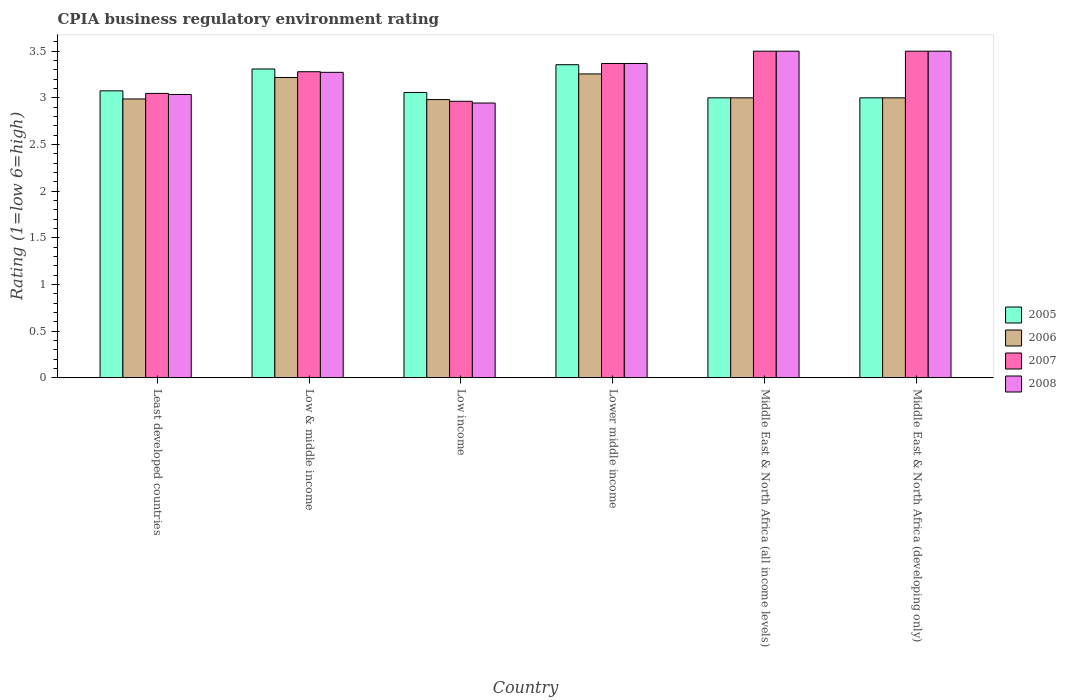Are the number of bars per tick equal to the number of legend labels?
Make the answer very short. Yes. Are the number of bars on each tick of the X-axis equal?
Provide a short and direct response. Yes. How many bars are there on the 6th tick from the left?
Provide a succinct answer. 4. How many bars are there on the 4th tick from the right?
Your answer should be very brief. 4. In how many cases, is the number of bars for a given country not equal to the number of legend labels?
Your response must be concise. 0. What is the CPIA rating in 2006 in Low & middle income?
Give a very brief answer. 3.22. Across all countries, what is the maximum CPIA rating in 2005?
Keep it short and to the point. 3.36. Across all countries, what is the minimum CPIA rating in 2007?
Make the answer very short. 2.96. In which country was the CPIA rating in 2008 maximum?
Your response must be concise. Middle East & North Africa (all income levels). What is the total CPIA rating in 2008 in the graph?
Your answer should be very brief. 19.62. What is the difference between the CPIA rating in 2008 in Low & middle income and that in Lower middle income?
Make the answer very short. -0.1. What is the difference between the CPIA rating in 2007 in Low income and the CPIA rating in 2006 in Lower middle income?
Offer a terse response. -0.29. What is the average CPIA rating in 2005 per country?
Your answer should be very brief. 3.13. What is the difference between the CPIA rating of/in 2005 and CPIA rating of/in 2007 in Low & middle income?
Your response must be concise. 0.03. What is the ratio of the CPIA rating in 2005 in Lower middle income to that in Middle East & North Africa (all income levels)?
Ensure brevity in your answer.  1.12. What is the difference between the highest and the second highest CPIA rating in 2008?
Offer a terse response. -0.13. What is the difference between the highest and the lowest CPIA rating in 2006?
Provide a short and direct response. 0.27. In how many countries, is the CPIA rating in 2008 greater than the average CPIA rating in 2008 taken over all countries?
Ensure brevity in your answer.  4. Is the sum of the CPIA rating in 2008 in Low income and Middle East & North Africa (developing only) greater than the maximum CPIA rating in 2005 across all countries?
Your response must be concise. Yes. Is it the case that in every country, the sum of the CPIA rating in 2008 and CPIA rating in 2005 is greater than the sum of CPIA rating in 2006 and CPIA rating in 2007?
Provide a short and direct response. No. What does the 1st bar from the left in Middle East & North Africa (all income levels) represents?
Your answer should be compact. 2005. Is it the case that in every country, the sum of the CPIA rating in 2007 and CPIA rating in 2008 is greater than the CPIA rating in 2006?
Give a very brief answer. Yes. How many bars are there?
Offer a very short reply. 24. What is the difference between two consecutive major ticks on the Y-axis?
Keep it short and to the point. 0.5. Are the values on the major ticks of Y-axis written in scientific E-notation?
Your response must be concise. No. Where does the legend appear in the graph?
Ensure brevity in your answer.  Center right. What is the title of the graph?
Ensure brevity in your answer.  CPIA business regulatory environment rating. What is the label or title of the X-axis?
Your answer should be very brief. Country. What is the Rating (1=low 6=high) of 2005 in Least developed countries?
Keep it short and to the point. 3.08. What is the Rating (1=low 6=high) in 2006 in Least developed countries?
Your answer should be compact. 2.99. What is the Rating (1=low 6=high) in 2007 in Least developed countries?
Give a very brief answer. 3.05. What is the Rating (1=low 6=high) of 2008 in Least developed countries?
Keep it short and to the point. 3.04. What is the Rating (1=low 6=high) of 2005 in Low & middle income?
Provide a short and direct response. 3.31. What is the Rating (1=low 6=high) in 2006 in Low & middle income?
Give a very brief answer. 3.22. What is the Rating (1=low 6=high) in 2007 in Low & middle income?
Your response must be concise. 3.28. What is the Rating (1=low 6=high) in 2008 in Low & middle income?
Provide a short and direct response. 3.27. What is the Rating (1=low 6=high) in 2005 in Low income?
Offer a very short reply. 3.06. What is the Rating (1=low 6=high) of 2006 in Low income?
Provide a short and direct response. 2.98. What is the Rating (1=low 6=high) in 2007 in Low income?
Provide a short and direct response. 2.96. What is the Rating (1=low 6=high) of 2008 in Low income?
Provide a short and direct response. 2.94. What is the Rating (1=low 6=high) in 2005 in Lower middle income?
Offer a terse response. 3.36. What is the Rating (1=low 6=high) of 2006 in Lower middle income?
Give a very brief answer. 3.26. What is the Rating (1=low 6=high) in 2007 in Lower middle income?
Provide a short and direct response. 3.37. What is the Rating (1=low 6=high) of 2008 in Lower middle income?
Offer a terse response. 3.37. What is the Rating (1=low 6=high) of 2007 in Middle East & North Africa (all income levels)?
Your answer should be compact. 3.5. What is the Rating (1=low 6=high) in 2008 in Middle East & North Africa (all income levels)?
Offer a terse response. 3.5. Across all countries, what is the maximum Rating (1=low 6=high) in 2005?
Keep it short and to the point. 3.36. Across all countries, what is the maximum Rating (1=low 6=high) of 2006?
Your answer should be very brief. 3.26. Across all countries, what is the maximum Rating (1=low 6=high) in 2007?
Your answer should be compact. 3.5. Across all countries, what is the minimum Rating (1=low 6=high) of 2006?
Offer a terse response. 2.98. Across all countries, what is the minimum Rating (1=low 6=high) of 2007?
Keep it short and to the point. 2.96. Across all countries, what is the minimum Rating (1=low 6=high) in 2008?
Your answer should be compact. 2.94. What is the total Rating (1=low 6=high) of 2005 in the graph?
Provide a succinct answer. 18.8. What is the total Rating (1=low 6=high) in 2006 in the graph?
Offer a very short reply. 18.44. What is the total Rating (1=low 6=high) in 2007 in the graph?
Make the answer very short. 19.66. What is the total Rating (1=low 6=high) of 2008 in the graph?
Ensure brevity in your answer.  19.62. What is the difference between the Rating (1=low 6=high) in 2005 in Least developed countries and that in Low & middle income?
Provide a short and direct response. -0.23. What is the difference between the Rating (1=low 6=high) of 2006 in Least developed countries and that in Low & middle income?
Provide a succinct answer. -0.23. What is the difference between the Rating (1=low 6=high) of 2007 in Least developed countries and that in Low & middle income?
Provide a short and direct response. -0.23. What is the difference between the Rating (1=low 6=high) of 2008 in Least developed countries and that in Low & middle income?
Make the answer very short. -0.24. What is the difference between the Rating (1=low 6=high) of 2005 in Least developed countries and that in Low income?
Your answer should be compact. 0.02. What is the difference between the Rating (1=low 6=high) in 2006 in Least developed countries and that in Low income?
Your response must be concise. 0.01. What is the difference between the Rating (1=low 6=high) of 2007 in Least developed countries and that in Low income?
Your answer should be very brief. 0.08. What is the difference between the Rating (1=low 6=high) in 2008 in Least developed countries and that in Low income?
Offer a terse response. 0.09. What is the difference between the Rating (1=low 6=high) of 2005 in Least developed countries and that in Lower middle income?
Offer a terse response. -0.28. What is the difference between the Rating (1=low 6=high) in 2006 in Least developed countries and that in Lower middle income?
Your answer should be compact. -0.27. What is the difference between the Rating (1=low 6=high) in 2007 in Least developed countries and that in Lower middle income?
Offer a very short reply. -0.32. What is the difference between the Rating (1=low 6=high) in 2008 in Least developed countries and that in Lower middle income?
Keep it short and to the point. -0.33. What is the difference between the Rating (1=low 6=high) in 2005 in Least developed countries and that in Middle East & North Africa (all income levels)?
Give a very brief answer. 0.07. What is the difference between the Rating (1=low 6=high) in 2006 in Least developed countries and that in Middle East & North Africa (all income levels)?
Ensure brevity in your answer.  -0.01. What is the difference between the Rating (1=low 6=high) in 2007 in Least developed countries and that in Middle East & North Africa (all income levels)?
Ensure brevity in your answer.  -0.45. What is the difference between the Rating (1=low 6=high) of 2008 in Least developed countries and that in Middle East & North Africa (all income levels)?
Your answer should be very brief. -0.46. What is the difference between the Rating (1=low 6=high) of 2005 in Least developed countries and that in Middle East & North Africa (developing only)?
Give a very brief answer. 0.07. What is the difference between the Rating (1=low 6=high) of 2006 in Least developed countries and that in Middle East & North Africa (developing only)?
Keep it short and to the point. -0.01. What is the difference between the Rating (1=low 6=high) of 2007 in Least developed countries and that in Middle East & North Africa (developing only)?
Give a very brief answer. -0.45. What is the difference between the Rating (1=low 6=high) in 2008 in Least developed countries and that in Middle East & North Africa (developing only)?
Offer a terse response. -0.46. What is the difference between the Rating (1=low 6=high) in 2005 in Low & middle income and that in Low income?
Give a very brief answer. 0.25. What is the difference between the Rating (1=low 6=high) in 2006 in Low & middle income and that in Low income?
Ensure brevity in your answer.  0.24. What is the difference between the Rating (1=low 6=high) in 2007 in Low & middle income and that in Low income?
Offer a very short reply. 0.32. What is the difference between the Rating (1=low 6=high) in 2008 in Low & middle income and that in Low income?
Keep it short and to the point. 0.33. What is the difference between the Rating (1=low 6=high) in 2005 in Low & middle income and that in Lower middle income?
Your answer should be compact. -0.05. What is the difference between the Rating (1=low 6=high) of 2006 in Low & middle income and that in Lower middle income?
Your answer should be compact. -0.04. What is the difference between the Rating (1=low 6=high) of 2007 in Low & middle income and that in Lower middle income?
Offer a terse response. -0.09. What is the difference between the Rating (1=low 6=high) in 2008 in Low & middle income and that in Lower middle income?
Provide a short and direct response. -0.1. What is the difference between the Rating (1=low 6=high) in 2005 in Low & middle income and that in Middle East & North Africa (all income levels)?
Give a very brief answer. 0.31. What is the difference between the Rating (1=low 6=high) of 2006 in Low & middle income and that in Middle East & North Africa (all income levels)?
Keep it short and to the point. 0.22. What is the difference between the Rating (1=low 6=high) of 2007 in Low & middle income and that in Middle East & North Africa (all income levels)?
Provide a short and direct response. -0.22. What is the difference between the Rating (1=low 6=high) in 2008 in Low & middle income and that in Middle East & North Africa (all income levels)?
Provide a short and direct response. -0.23. What is the difference between the Rating (1=low 6=high) of 2005 in Low & middle income and that in Middle East & North Africa (developing only)?
Keep it short and to the point. 0.31. What is the difference between the Rating (1=low 6=high) of 2006 in Low & middle income and that in Middle East & North Africa (developing only)?
Ensure brevity in your answer.  0.22. What is the difference between the Rating (1=low 6=high) of 2007 in Low & middle income and that in Middle East & North Africa (developing only)?
Your response must be concise. -0.22. What is the difference between the Rating (1=low 6=high) of 2008 in Low & middle income and that in Middle East & North Africa (developing only)?
Your response must be concise. -0.23. What is the difference between the Rating (1=low 6=high) in 2005 in Low income and that in Lower middle income?
Your answer should be compact. -0.3. What is the difference between the Rating (1=low 6=high) in 2006 in Low income and that in Lower middle income?
Offer a terse response. -0.27. What is the difference between the Rating (1=low 6=high) of 2007 in Low income and that in Lower middle income?
Provide a short and direct response. -0.41. What is the difference between the Rating (1=low 6=high) in 2008 in Low income and that in Lower middle income?
Your response must be concise. -0.42. What is the difference between the Rating (1=low 6=high) in 2005 in Low income and that in Middle East & North Africa (all income levels)?
Make the answer very short. 0.06. What is the difference between the Rating (1=low 6=high) of 2006 in Low income and that in Middle East & North Africa (all income levels)?
Your answer should be compact. -0.02. What is the difference between the Rating (1=low 6=high) of 2007 in Low income and that in Middle East & North Africa (all income levels)?
Keep it short and to the point. -0.54. What is the difference between the Rating (1=low 6=high) in 2008 in Low income and that in Middle East & North Africa (all income levels)?
Your response must be concise. -0.56. What is the difference between the Rating (1=low 6=high) of 2005 in Low income and that in Middle East & North Africa (developing only)?
Keep it short and to the point. 0.06. What is the difference between the Rating (1=low 6=high) in 2006 in Low income and that in Middle East & North Africa (developing only)?
Ensure brevity in your answer.  -0.02. What is the difference between the Rating (1=low 6=high) in 2007 in Low income and that in Middle East & North Africa (developing only)?
Your response must be concise. -0.54. What is the difference between the Rating (1=low 6=high) in 2008 in Low income and that in Middle East & North Africa (developing only)?
Make the answer very short. -0.56. What is the difference between the Rating (1=low 6=high) in 2005 in Lower middle income and that in Middle East & North Africa (all income levels)?
Provide a short and direct response. 0.36. What is the difference between the Rating (1=low 6=high) in 2006 in Lower middle income and that in Middle East & North Africa (all income levels)?
Keep it short and to the point. 0.26. What is the difference between the Rating (1=low 6=high) of 2007 in Lower middle income and that in Middle East & North Africa (all income levels)?
Your response must be concise. -0.13. What is the difference between the Rating (1=low 6=high) of 2008 in Lower middle income and that in Middle East & North Africa (all income levels)?
Your answer should be compact. -0.13. What is the difference between the Rating (1=low 6=high) in 2005 in Lower middle income and that in Middle East & North Africa (developing only)?
Offer a very short reply. 0.36. What is the difference between the Rating (1=low 6=high) in 2006 in Lower middle income and that in Middle East & North Africa (developing only)?
Your answer should be very brief. 0.26. What is the difference between the Rating (1=low 6=high) in 2007 in Lower middle income and that in Middle East & North Africa (developing only)?
Make the answer very short. -0.13. What is the difference between the Rating (1=low 6=high) in 2008 in Lower middle income and that in Middle East & North Africa (developing only)?
Provide a succinct answer. -0.13. What is the difference between the Rating (1=low 6=high) in 2007 in Middle East & North Africa (all income levels) and that in Middle East & North Africa (developing only)?
Your response must be concise. 0. What is the difference between the Rating (1=low 6=high) in 2008 in Middle East & North Africa (all income levels) and that in Middle East & North Africa (developing only)?
Ensure brevity in your answer.  0. What is the difference between the Rating (1=low 6=high) of 2005 in Least developed countries and the Rating (1=low 6=high) of 2006 in Low & middle income?
Your answer should be compact. -0.14. What is the difference between the Rating (1=low 6=high) in 2005 in Least developed countries and the Rating (1=low 6=high) in 2007 in Low & middle income?
Your response must be concise. -0.2. What is the difference between the Rating (1=low 6=high) of 2005 in Least developed countries and the Rating (1=low 6=high) of 2008 in Low & middle income?
Offer a very short reply. -0.2. What is the difference between the Rating (1=low 6=high) of 2006 in Least developed countries and the Rating (1=low 6=high) of 2007 in Low & middle income?
Your answer should be compact. -0.29. What is the difference between the Rating (1=low 6=high) of 2006 in Least developed countries and the Rating (1=low 6=high) of 2008 in Low & middle income?
Give a very brief answer. -0.29. What is the difference between the Rating (1=low 6=high) of 2007 in Least developed countries and the Rating (1=low 6=high) of 2008 in Low & middle income?
Your response must be concise. -0.23. What is the difference between the Rating (1=low 6=high) of 2005 in Least developed countries and the Rating (1=low 6=high) of 2006 in Low income?
Offer a very short reply. 0.09. What is the difference between the Rating (1=low 6=high) of 2005 in Least developed countries and the Rating (1=low 6=high) of 2007 in Low income?
Keep it short and to the point. 0.11. What is the difference between the Rating (1=low 6=high) of 2005 in Least developed countries and the Rating (1=low 6=high) of 2008 in Low income?
Offer a terse response. 0.13. What is the difference between the Rating (1=low 6=high) of 2006 in Least developed countries and the Rating (1=low 6=high) of 2007 in Low income?
Give a very brief answer. 0.03. What is the difference between the Rating (1=low 6=high) in 2006 in Least developed countries and the Rating (1=low 6=high) in 2008 in Low income?
Ensure brevity in your answer.  0.04. What is the difference between the Rating (1=low 6=high) in 2007 in Least developed countries and the Rating (1=low 6=high) in 2008 in Low income?
Your response must be concise. 0.1. What is the difference between the Rating (1=low 6=high) in 2005 in Least developed countries and the Rating (1=low 6=high) in 2006 in Lower middle income?
Give a very brief answer. -0.18. What is the difference between the Rating (1=low 6=high) of 2005 in Least developed countries and the Rating (1=low 6=high) of 2007 in Lower middle income?
Ensure brevity in your answer.  -0.29. What is the difference between the Rating (1=low 6=high) in 2005 in Least developed countries and the Rating (1=low 6=high) in 2008 in Lower middle income?
Offer a terse response. -0.29. What is the difference between the Rating (1=low 6=high) in 2006 in Least developed countries and the Rating (1=low 6=high) in 2007 in Lower middle income?
Your answer should be compact. -0.38. What is the difference between the Rating (1=low 6=high) in 2006 in Least developed countries and the Rating (1=low 6=high) in 2008 in Lower middle income?
Provide a succinct answer. -0.38. What is the difference between the Rating (1=low 6=high) of 2007 in Least developed countries and the Rating (1=low 6=high) of 2008 in Lower middle income?
Provide a short and direct response. -0.32. What is the difference between the Rating (1=low 6=high) of 2005 in Least developed countries and the Rating (1=low 6=high) of 2006 in Middle East & North Africa (all income levels)?
Your answer should be very brief. 0.07. What is the difference between the Rating (1=low 6=high) in 2005 in Least developed countries and the Rating (1=low 6=high) in 2007 in Middle East & North Africa (all income levels)?
Your answer should be very brief. -0.42. What is the difference between the Rating (1=low 6=high) in 2005 in Least developed countries and the Rating (1=low 6=high) in 2008 in Middle East & North Africa (all income levels)?
Your answer should be very brief. -0.42. What is the difference between the Rating (1=low 6=high) of 2006 in Least developed countries and the Rating (1=low 6=high) of 2007 in Middle East & North Africa (all income levels)?
Offer a very short reply. -0.51. What is the difference between the Rating (1=low 6=high) of 2006 in Least developed countries and the Rating (1=low 6=high) of 2008 in Middle East & North Africa (all income levels)?
Your response must be concise. -0.51. What is the difference between the Rating (1=low 6=high) in 2007 in Least developed countries and the Rating (1=low 6=high) in 2008 in Middle East & North Africa (all income levels)?
Your answer should be compact. -0.45. What is the difference between the Rating (1=low 6=high) of 2005 in Least developed countries and the Rating (1=low 6=high) of 2006 in Middle East & North Africa (developing only)?
Ensure brevity in your answer.  0.07. What is the difference between the Rating (1=low 6=high) in 2005 in Least developed countries and the Rating (1=low 6=high) in 2007 in Middle East & North Africa (developing only)?
Provide a succinct answer. -0.42. What is the difference between the Rating (1=low 6=high) in 2005 in Least developed countries and the Rating (1=low 6=high) in 2008 in Middle East & North Africa (developing only)?
Provide a short and direct response. -0.42. What is the difference between the Rating (1=low 6=high) of 2006 in Least developed countries and the Rating (1=low 6=high) of 2007 in Middle East & North Africa (developing only)?
Your answer should be compact. -0.51. What is the difference between the Rating (1=low 6=high) of 2006 in Least developed countries and the Rating (1=low 6=high) of 2008 in Middle East & North Africa (developing only)?
Provide a succinct answer. -0.51. What is the difference between the Rating (1=low 6=high) of 2007 in Least developed countries and the Rating (1=low 6=high) of 2008 in Middle East & North Africa (developing only)?
Your response must be concise. -0.45. What is the difference between the Rating (1=low 6=high) in 2005 in Low & middle income and the Rating (1=low 6=high) in 2006 in Low income?
Offer a terse response. 0.33. What is the difference between the Rating (1=low 6=high) in 2005 in Low & middle income and the Rating (1=low 6=high) in 2007 in Low income?
Offer a very short reply. 0.35. What is the difference between the Rating (1=low 6=high) of 2005 in Low & middle income and the Rating (1=low 6=high) of 2008 in Low income?
Provide a succinct answer. 0.36. What is the difference between the Rating (1=low 6=high) in 2006 in Low & middle income and the Rating (1=low 6=high) in 2007 in Low income?
Make the answer very short. 0.26. What is the difference between the Rating (1=low 6=high) in 2006 in Low & middle income and the Rating (1=low 6=high) in 2008 in Low income?
Give a very brief answer. 0.27. What is the difference between the Rating (1=low 6=high) in 2007 in Low & middle income and the Rating (1=low 6=high) in 2008 in Low income?
Provide a succinct answer. 0.34. What is the difference between the Rating (1=low 6=high) in 2005 in Low & middle income and the Rating (1=low 6=high) in 2006 in Lower middle income?
Your answer should be very brief. 0.05. What is the difference between the Rating (1=low 6=high) of 2005 in Low & middle income and the Rating (1=low 6=high) of 2007 in Lower middle income?
Your answer should be compact. -0.06. What is the difference between the Rating (1=low 6=high) in 2005 in Low & middle income and the Rating (1=low 6=high) in 2008 in Lower middle income?
Provide a succinct answer. -0.06. What is the difference between the Rating (1=low 6=high) of 2006 in Low & middle income and the Rating (1=low 6=high) of 2007 in Lower middle income?
Offer a very short reply. -0.15. What is the difference between the Rating (1=low 6=high) of 2006 in Low & middle income and the Rating (1=low 6=high) of 2008 in Lower middle income?
Ensure brevity in your answer.  -0.15. What is the difference between the Rating (1=low 6=high) of 2007 in Low & middle income and the Rating (1=low 6=high) of 2008 in Lower middle income?
Your answer should be very brief. -0.09. What is the difference between the Rating (1=low 6=high) in 2005 in Low & middle income and the Rating (1=low 6=high) in 2006 in Middle East & North Africa (all income levels)?
Provide a short and direct response. 0.31. What is the difference between the Rating (1=low 6=high) of 2005 in Low & middle income and the Rating (1=low 6=high) of 2007 in Middle East & North Africa (all income levels)?
Provide a succinct answer. -0.19. What is the difference between the Rating (1=low 6=high) of 2005 in Low & middle income and the Rating (1=low 6=high) of 2008 in Middle East & North Africa (all income levels)?
Keep it short and to the point. -0.19. What is the difference between the Rating (1=low 6=high) in 2006 in Low & middle income and the Rating (1=low 6=high) in 2007 in Middle East & North Africa (all income levels)?
Make the answer very short. -0.28. What is the difference between the Rating (1=low 6=high) in 2006 in Low & middle income and the Rating (1=low 6=high) in 2008 in Middle East & North Africa (all income levels)?
Offer a very short reply. -0.28. What is the difference between the Rating (1=low 6=high) in 2007 in Low & middle income and the Rating (1=low 6=high) in 2008 in Middle East & North Africa (all income levels)?
Make the answer very short. -0.22. What is the difference between the Rating (1=low 6=high) in 2005 in Low & middle income and the Rating (1=low 6=high) in 2006 in Middle East & North Africa (developing only)?
Your answer should be very brief. 0.31. What is the difference between the Rating (1=low 6=high) of 2005 in Low & middle income and the Rating (1=low 6=high) of 2007 in Middle East & North Africa (developing only)?
Provide a short and direct response. -0.19. What is the difference between the Rating (1=low 6=high) of 2005 in Low & middle income and the Rating (1=low 6=high) of 2008 in Middle East & North Africa (developing only)?
Your response must be concise. -0.19. What is the difference between the Rating (1=low 6=high) in 2006 in Low & middle income and the Rating (1=low 6=high) in 2007 in Middle East & North Africa (developing only)?
Offer a terse response. -0.28. What is the difference between the Rating (1=low 6=high) in 2006 in Low & middle income and the Rating (1=low 6=high) in 2008 in Middle East & North Africa (developing only)?
Your answer should be very brief. -0.28. What is the difference between the Rating (1=low 6=high) of 2007 in Low & middle income and the Rating (1=low 6=high) of 2008 in Middle East & North Africa (developing only)?
Give a very brief answer. -0.22. What is the difference between the Rating (1=low 6=high) in 2005 in Low income and the Rating (1=low 6=high) in 2006 in Lower middle income?
Keep it short and to the point. -0.2. What is the difference between the Rating (1=low 6=high) in 2005 in Low income and the Rating (1=low 6=high) in 2007 in Lower middle income?
Provide a succinct answer. -0.31. What is the difference between the Rating (1=low 6=high) in 2005 in Low income and the Rating (1=low 6=high) in 2008 in Lower middle income?
Give a very brief answer. -0.31. What is the difference between the Rating (1=low 6=high) in 2006 in Low income and the Rating (1=low 6=high) in 2007 in Lower middle income?
Ensure brevity in your answer.  -0.39. What is the difference between the Rating (1=low 6=high) in 2006 in Low income and the Rating (1=low 6=high) in 2008 in Lower middle income?
Your response must be concise. -0.39. What is the difference between the Rating (1=low 6=high) of 2007 in Low income and the Rating (1=low 6=high) of 2008 in Lower middle income?
Ensure brevity in your answer.  -0.41. What is the difference between the Rating (1=low 6=high) of 2005 in Low income and the Rating (1=low 6=high) of 2006 in Middle East & North Africa (all income levels)?
Offer a very short reply. 0.06. What is the difference between the Rating (1=low 6=high) of 2005 in Low income and the Rating (1=low 6=high) of 2007 in Middle East & North Africa (all income levels)?
Make the answer very short. -0.44. What is the difference between the Rating (1=low 6=high) of 2005 in Low income and the Rating (1=low 6=high) of 2008 in Middle East & North Africa (all income levels)?
Keep it short and to the point. -0.44. What is the difference between the Rating (1=low 6=high) in 2006 in Low income and the Rating (1=low 6=high) in 2007 in Middle East & North Africa (all income levels)?
Your answer should be compact. -0.52. What is the difference between the Rating (1=low 6=high) of 2006 in Low income and the Rating (1=low 6=high) of 2008 in Middle East & North Africa (all income levels)?
Make the answer very short. -0.52. What is the difference between the Rating (1=low 6=high) of 2007 in Low income and the Rating (1=low 6=high) of 2008 in Middle East & North Africa (all income levels)?
Make the answer very short. -0.54. What is the difference between the Rating (1=low 6=high) of 2005 in Low income and the Rating (1=low 6=high) of 2006 in Middle East & North Africa (developing only)?
Make the answer very short. 0.06. What is the difference between the Rating (1=low 6=high) of 2005 in Low income and the Rating (1=low 6=high) of 2007 in Middle East & North Africa (developing only)?
Provide a succinct answer. -0.44. What is the difference between the Rating (1=low 6=high) of 2005 in Low income and the Rating (1=low 6=high) of 2008 in Middle East & North Africa (developing only)?
Make the answer very short. -0.44. What is the difference between the Rating (1=low 6=high) of 2006 in Low income and the Rating (1=low 6=high) of 2007 in Middle East & North Africa (developing only)?
Your answer should be very brief. -0.52. What is the difference between the Rating (1=low 6=high) in 2006 in Low income and the Rating (1=low 6=high) in 2008 in Middle East & North Africa (developing only)?
Your answer should be very brief. -0.52. What is the difference between the Rating (1=low 6=high) in 2007 in Low income and the Rating (1=low 6=high) in 2008 in Middle East & North Africa (developing only)?
Offer a very short reply. -0.54. What is the difference between the Rating (1=low 6=high) of 2005 in Lower middle income and the Rating (1=low 6=high) of 2006 in Middle East & North Africa (all income levels)?
Make the answer very short. 0.36. What is the difference between the Rating (1=low 6=high) of 2005 in Lower middle income and the Rating (1=low 6=high) of 2007 in Middle East & North Africa (all income levels)?
Your response must be concise. -0.14. What is the difference between the Rating (1=low 6=high) of 2005 in Lower middle income and the Rating (1=low 6=high) of 2008 in Middle East & North Africa (all income levels)?
Provide a short and direct response. -0.14. What is the difference between the Rating (1=low 6=high) of 2006 in Lower middle income and the Rating (1=low 6=high) of 2007 in Middle East & North Africa (all income levels)?
Keep it short and to the point. -0.24. What is the difference between the Rating (1=low 6=high) of 2006 in Lower middle income and the Rating (1=low 6=high) of 2008 in Middle East & North Africa (all income levels)?
Offer a very short reply. -0.24. What is the difference between the Rating (1=low 6=high) of 2007 in Lower middle income and the Rating (1=low 6=high) of 2008 in Middle East & North Africa (all income levels)?
Your response must be concise. -0.13. What is the difference between the Rating (1=low 6=high) of 2005 in Lower middle income and the Rating (1=low 6=high) of 2006 in Middle East & North Africa (developing only)?
Make the answer very short. 0.36. What is the difference between the Rating (1=low 6=high) of 2005 in Lower middle income and the Rating (1=low 6=high) of 2007 in Middle East & North Africa (developing only)?
Keep it short and to the point. -0.14. What is the difference between the Rating (1=low 6=high) in 2005 in Lower middle income and the Rating (1=low 6=high) in 2008 in Middle East & North Africa (developing only)?
Provide a succinct answer. -0.14. What is the difference between the Rating (1=low 6=high) in 2006 in Lower middle income and the Rating (1=low 6=high) in 2007 in Middle East & North Africa (developing only)?
Ensure brevity in your answer.  -0.24. What is the difference between the Rating (1=low 6=high) of 2006 in Lower middle income and the Rating (1=low 6=high) of 2008 in Middle East & North Africa (developing only)?
Provide a short and direct response. -0.24. What is the difference between the Rating (1=low 6=high) in 2007 in Lower middle income and the Rating (1=low 6=high) in 2008 in Middle East & North Africa (developing only)?
Give a very brief answer. -0.13. What is the difference between the Rating (1=low 6=high) in 2005 in Middle East & North Africa (all income levels) and the Rating (1=low 6=high) in 2007 in Middle East & North Africa (developing only)?
Keep it short and to the point. -0.5. What is the difference between the Rating (1=low 6=high) of 2005 in Middle East & North Africa (all income levels) and the Rating (1=low 6=high) of 2008 in Middle East & North Africa (developing only)?
Your answer should be very brief. -0.5. What is the difference between the Rating (1=low 6=high) of 2006 in Middle East & North Africa (all income levels) and the Rating (1=low 6=high) of 2007 in Middle East & North Africa (developing only)?
Keep it short and to the point. -0.5. What is the average Rating (1=low 6=high) of 2005 per country?
Your answer should be compact. 3.13. What is the average Rating (1=low 6=high) in 2006 per country?
Provide a succinct answer. 3.07. What is the average Rating (1=low 6=high) in 2007 per country?
Ensure brevity in your answer.  3.28. What is the average Rating (1=low 6=high) in 2008 per country?
Your answer should be very brief. 3.27. What is the difference between the Rating (1=low 6=high) in 2005 and Rating (1=low 6=high) in 2006 in Least developed countries?
Make the answer very short. 0.09. What is the difference between the Rating (1=low 6=high) in 2005 and Rating (1=low 6=high) in 2007 in Least developed countries?
Your answer should be very brief. 0.03. What is the difference between the Rating (1=low 6=high) of 2005 and Rating (1=low 6=high) of 2008 in Least developed countries?
Provide a succinct answer. 0.04. What is the difference between the Rating (1=low 6=high) of 2006 and Rating (1=low 6=high) of 2007 in Least developed countries?
Provide a succinct answer. -0.06. What is the difference between the Rating (1=low 6=high) in 2006 and Rating (1=low 6=high) in 2008 in Least developed countries?
Keep it short and to the point. -0.05. What is the difference between the Rating (1=low 6=high) in 2007 and Rating (1=low 6=high) in 2008 in Least developed countries?
Give a very brief answer. 0.01. What is the difference between the Rating (1=low 6=high) in 2005 and Rating (1=low 6=high) in 2006 in Low & middle income?
Your answer should be compact. 0.09. What is the difference between the Rating (1=low 6=high) in 2005 and Rating (1=low 6=high) in 2007 in Low & middle income?
Your response must be concise. 0.03. What is the difference between the Rating (1=low 6=high) of 2005 and Rating (1=low 6=high) of 2008 in Low & middle income?
Offer a very short reply. 0.04. What is the difference between the Rating (1=low 6=high) in 2006 and Rating (1=low 6=high) in 2007 in Low & middle income?
Keep it short and to the point. -0.06. What is the difference between the Rating (1=low 6=high) in 2006 and Rating (1=low 6=high) in 2008 in Low & middle income?
Your answer should be very brief. -0.06. What is the difference between the Rating (1=low 6=high) of 2007 and Rating (1=low 6=high) of 2008 in Low & middle income?
Offer a very short reply. 0.01. What is the difference between the Rating (1=low 6=high) in 2005 and Rating (1=low 6=high) in 2006 in Low income?
Your response must be concise. 0.08. What is the difference between the Rating (1=low 6=high) of 2005 and Rating (1=low 6=high) of 2007 in Low income?
Give a very brief answer. 0.09. What is the difference between the Rating (1=low 6=high) in 2005 and Rating (1=low 6=high) in 2008 in Low income?
Your answer should be very brief. 0.11. What is the difference between the Rating (1=low 6=high) in 2006 and Rating (1=low 6=high) in 2007 in Low income?
Make the answer very short. 0.02. What is the difference between the Rating (1=low 6=high) of 2006 and Rating (1=low 6=high) of 2008 in Low income?
Provide a short and direct response. 0.04. What is the difference between the Rating (1=low 6=high) in 2007 and Rating (1=low 6=high) in 2008 in Low income?
Provide a succinct answer. 0.02. What is the difference between the Rating (1=low 6=high) of 2005 and Rating (1=low 6=high) of 2006 in Lower middle income?
Offer a terse response. 0.1. What is the difference between the Rating (1=low 6=high) in 2005 and Rating (1=low 6=high) in 2007 in Lower middle income?
Your answer should be very brief. -0.01. What is the difference between the Rating (1=low 6=high) in 2005 and Rating (1=low 6=high) in 2008 in Lower middle income?
Provide a succinct answer. -0.01. What is the difference between the Rating (1=low 6=high) in 2006 and Rating (1=low 6=high) in 2007 in Lower middle income?
Make the answer very short. -0.11. What is the difference between the Rating (1=low 6=high) in 2006 and Rating (1=low 6=high) in 2008 in Lower middle income?
Keep it short and to the point. -0.11. What is the difference between the Rating (1=low 6=high) in 2005 and Rating (1=low 6=high) in 2006 in Middle East & North Africa (all income levels)?
Offer a terse response. 0. What is the difference between the Rating (1=low 6=high) in 2005 and Rating (1=low 6=high) in 2008 in Middle East & North Africa (all income levels)?
Provide a succinct answer. -0.5. What is the difference between the Rating (1=low 6=high) in 2006 and Rating (1=low 6=high) in 2007 in Middle East & North Africa (all income levels)?
Provide a short and direct response. -0.5. What is the difference between the Rating (1=low 6=high) of 2007 and Rating (1=low 6=high) of 2008 in Middle East & North Africa (all income levels)?
Your answer should be very brief. 0. What is the difference between the Rating (1=low 6=high) of 2005 and Rating (1=low 6=high) of 2007 in Middle East & North Africa (developing only)?
Your answer should be very brief. -0.5. What is the difference between the Rating (1=low 6=high) of 2005 and Rating (1=low 6=high) of 2008 in Middle East & North Africa (developing only)?
Provide a succinct answer. -0.5. What is the difference between the Rating (1=low 6=high) in 2006 and Rating (1=low 6=high) in 2007 in Middle East & North Africa (developing only)?
Your answer should be compact. -0.5. What is the ratio of the Rating (1=low 6=high) of 2005 in Least developed countries to that in Low & middle income?
Make the answer very short. 0.93. What is the ratio of the Rating (1=low 6=high) in 2007 in Least developed countries to that in Low & middle income?
Ensure brevity in your answer.  0.93. What is the ratio of the Rating (1=low 6=high) in 2008 in Least developed countries to that in Low & middle income?
Provide a succinct answer. 0.93. What is the ratio of the Rating (1=low 6=high) of 2006 in Least developed countries to that in Low income?
Your answer should be very brief. 1. What is the ratio of the Rating (1=low 6=high) in 2007 in Least developed countries to that in Low income?
Make the answer very short. 1.03. What is the ratio of the Rating (1=low 6=high) in 2008 in Least developed countries to that in Low income?
Your answer should be compact. 1.03. What is the ratio of the Rating (1=low 6=high) in 2005 in Least developed countries to that in Lower middle income?
Your response must be concise. 0.92. What is the ratio of the Rating (1=low 6=high) in 2006 in Least developed countries to that in Lower middle income?
Provide a short and direct response. 0.92. What is the ratio of the Rating (1=low 6=high) in 2007 in Least developed countries to that in Lower middle income?
Make the answer very short. 0.9. What is the ratio of the Rating (1=low 6=high) in 2008 in Least developed countries to that in Lower middle income?
Make the answer very short. 0.9. What is the ratio of the Rating (1=low 6=high) of 2007 in Least developed countries to that in Middle East & North Africa (all income levels)?
Ensure brevity in your answer.  0.87. What is the ratio of the Rating (1=low 6=high) in 2008 in Least developed countries to that in Middle East & North Africa (all income levels)?
Provide a short and direct response. 0.87. What is the ratio of the Rating (1=low 6=high) in 2006 in Least developed countries to that in Middle East & North Africa (developing only)?
Give a very brief answer. 1. What is the ratio of the Rating (1=low 6=high) of 2007 in Least developed countries to that in Middle East & North Africa (developing only)?
Make the answer very short. 0.87. What is the ratio of the Rating (1=low 6=high) in 2008 in Least developed countries to that in Middle East & North Africa (developing only)?
Your answer should be compact. 0.87. What is the ratio of the Rating (1=low 6=high) of 2005 in Low & middle income to that in Low income?
Your answer should be compact. 1.08. What is the ratio of the Rating (1=low 6=high) in 2006 in Low & middle income to that in Low income?
Make the answer very short. 1.08. What is the ratio of the Rating (1=low 6=high) in 2007 in Low & middle income to that in Low income?
Your response must be concise. 1.11. What is the ratio of the Rating (1=low 6=high) of 2008 in Low & middle income to that in Low income?
Ensure brevity in your answer.  1.11. What is the ratio of the Rating (1=low 6=high) in 2005 in Low & middle income to that in Lower middle income?
Give a very brief answer. 0.99. What is the ratio of the Rating (1=low 6=high) of 2007 in Low & middle income to that in Lower middle income?
Provide a short and direct response. 0.97. What is the ratio of the Rating (1=low 6=high) of 2008 in Low & middle income to that in Lower middle income?
Your answer should be very brief. 0.97. What is the ratio of the Rating (1=low 6=high) in 2005 in Low & middle income to that in Middle East & North Africa (all income levels)?
Ensure brevity in your answer.  1.1. What is the ratio of the Rating (1=low 6=high) of 2006 in Low & middle income to that in Middle East & North Africa (all income levels)?
Offer a terse response. 1.07. What is the ratio of the Rating (1=low 6=high) of 2007 in Low & middle income to that in Middle East & North Africa (all income levels)?
Your answer should be compact. 0.94. What is the ratio of the Rating (1=low 6=high) of 2008 in Low & middle income to that in Middle East & North Africa (all income levels)?
Your answer should be compact. 0.94. What is the ratio of the Rating (1=low 6=high) of 2005 in Low & middle income to that in Middle East & North Africa (developing only)?
Offer a terse response. 1.1. What is the ratio of the Rating (1=low 6=high) of 2006 in Low & middle income to that in Middle East & North Africa (developing only)?
Provide a succinct answer. 1.07. What is the ratio of the Rating (1=low 6=high) in 2007 in Low & middle income to that in Middle East & North Africa (developing only)?
Give a very brief answer. 0.94. What is the ratio of the Rating (1=low 6=high) in 2008 in Low & middle income to that in Middle East & North Africa (developing only)?
Offer a very short reply. 0.94. What is the ratio of the Rating (1=low 6=high) of 2005 in Low income to that in Lower middle income?
Your answer should be very brief. 0.91. What is the ratio of the Rating (1=low 6=high) of 2006 in Low income to that in Lower middle income?
Keep it short and to the point. 0.92. What is the ratio of the Rating (1=low 6=high) in 2007 in Low income to that in Lower middle income?
Offer a terse response. 0.88. What is the ratio of the Rating (1=low 6=high) of 2008 in Low income to that in Lower middle income?
Offer a terse response. 0.87. What is the ratio of the Rating (1=low 6=high) in 2005 in Low income to that in Middle East & North Africa (all income levels)?
Offer a terse response. 1.02. What is the ratio of the Rating (1=low 6=high) of 2006 in Low income to that in Middle East & North Africa (all income levels)?
Give a very brief answer. 0.99. What is the ratio of the Rating (1=low 6=high) in 2007 in Low income to that in Middle East & North Africa (all income levels)?
Give a very brief answer. 0.85. What is the ratio of the Rating (1=low 6=high) in 2008 in Low income to that in Middle East & North Africa (all income levels)?
Keep it short and to the point. 0.84. What is the ratio of the Rating (1=low 6=high) in 2005 in Low income to that in Middle East & North Africa (developing only)?
Your response must be concise. 1.02. What is the ratio of the Rating (1=low 6=high) in 2006 in Low income to that in Middle East & North Africa (developing only)?
Provide a succinct answer. 0.99. What is the ratio of the Rating (1=low 6=high) of 2007 in Low income to that in Middle East & North Africa (developing only)?
Give a very brief answer. 0.85. What is the ratio of the Rating (1=low 6=high) of 2008 in Low income to that in Middle East & North Africa (developing only)?
Make the answer very short. 0.84. What is the ratio of the Rating (1=low 6=high) in 2005 in Lower middle income to that in Middle East & North Africa (all income levels)?
Your answer should be compact. 1.12. What is the ratio of the Rating (1=low 6=high) in 2006 in Lower middle income to that in Middle East & North Africa (all income levels)?
Offer a terse response. 1.09. What is the ratio of the Rating (1=low 6=high) of 2007 in Lower middle income to that in Middle East & North Africa (all income levels)?
Provide a succinct answer. 0.96. What is the ratio of the Rating (1=low 6=high) of 2008 in Lower middle income to that in Middle East & North Africa (all income levels)?
Offer a very short reply. 0.96. What is the ratio of the Rating (1=low 6=high) of 2005 in Lower middle income to that in Middle East & North Africa (developing only)?
Offer a terse response. 1.12. What is the ratio of the Rating (1=low 6=high) in 2006 in Lower middle income to that in Middle East & North Africa (developing only)?
Give a very brief answer. 1.09. What is the ratio of the Rating (1=low 6=high) of 2007 in Lower middle income to that in Middle East & North Africa (developing only)?
Keep it short and to the point. 0.96. What is the ratio of the Rating (1=low 6=high) of 2008 in Lower middle income to that in Middle East & North Africa (developing only)?
Offer a terse response. 0.96. What is the ratio of the Rating (1=low 6=high) of 2005 in Middle East & North Africa (all income levels) to that in Middle East & North Africa (developing only)?
Provide a short and direct response. 1. What is the ratio of the Rating (1=low 6=high) of 2006 in Middle East & North Africa (all income levels) to that in Middle East & North Africa (developing only)?
Provide a short and direct response. 1. What is the ratio of the Rating (1=low 6=high) of 2007 in Middle East & North Africa (all income levels) to that in Middle East & North Africa (developing only)?
Give a very brief answer. 1. What is the ratio of the Rating (1=low 6=high) of 2008 in Middle East & North Africa (all income levels) to that in Middle East & North Africa (developing only)?
Your answer should be very brief. 1. What is the difference between the highest and the second highest Rating (1=low 6=high) of 2005?
Ensure brevity in your answer.  0.05. What is the difference between the highest and the second highest Rating (1=low 6=high) of 2006?
Your response must be concise. 0.04. What is the difference between the highest and the second highest Rating (1=low 6=high) of 2008?
Ensure brevity in your answer.  0. What is the difference between the highest and the lowest Rating (1=low 6=high) of 2005?
Ensure brevity in your answer.  0.36. What is the difference between the highest and the lowest Rating (1=low 6=high) in 2006?
Give a very brief answer. 0.27. What is the difference between the highest and the lowest Rating (1=low 6=high) of 2007?
Your answer should be compact. 0.54. What is the difference between the highest and the lowest Rating (1=low 6=high) of 2008?
Make the answer very short. 0.56. 